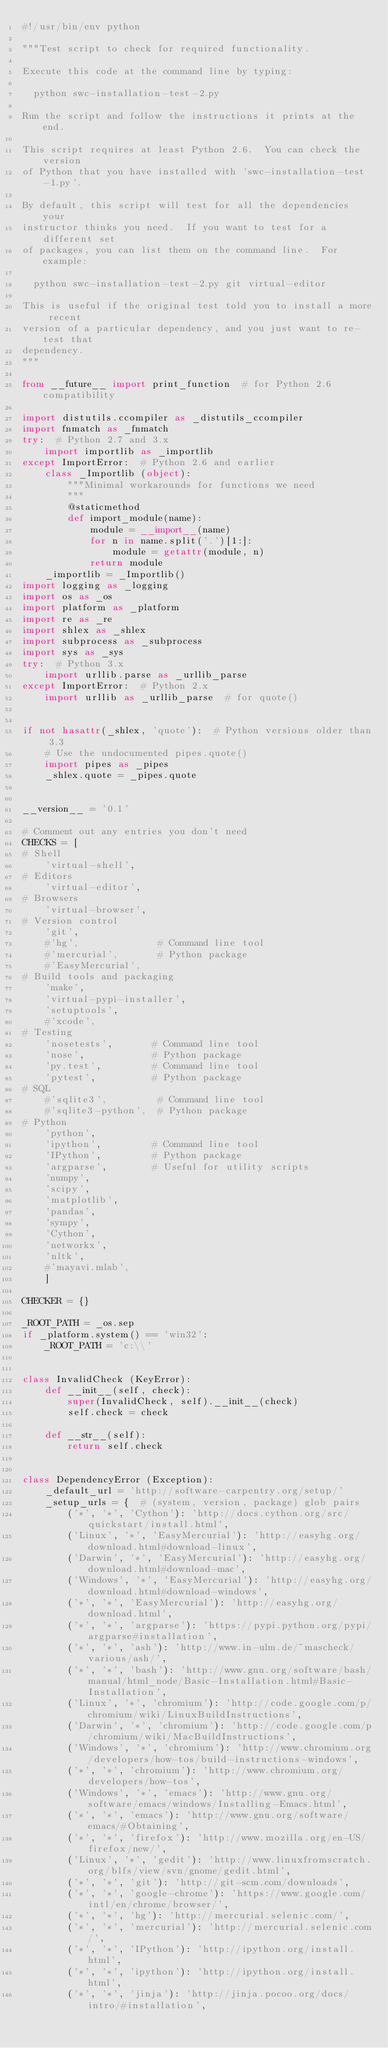Convert code to text. <code><loc_0><loc_0><loc_500><loc_500><_Python_>#!/usr/bin/env python

"""Test script to check for required functionality.

Execute this code at the command line by typing:

  python swc-installation-test-2.py

Run the script and follow the instructions it prints at the end.

This script requires at least Python 2.6.  You can check the version
of Python that you have installed with 'swc-installation-test-1.py'.

By default, this script will test for all the dependencies your
instructor thinks you need.  If you want to test for a different set
of packages, you can list them on the command line.  For example:

  python swc-installation-test-2.py git virtual-editor

This is useful if the original test told you to install a more recent
version of a particular dependency, and you just want to re-test that
dependency.
"""

from __future__ import print_function  # for Python 2.6 compatibility

import distutils.ccompiler as _distutils_ccompiler
import fnmatch as _fnmatch
try:  # Python 2.7 and 3.x
    import importlib as _importlib
except ImportError:  # Python 2.6 and earlier
    class _Importlib (object):
        """Minimal workarounds for functions we need
        """
        @staticmethod
        def import_module(name):
            module = __import__(name)
            for n in name.split('.')[1:]:
                module = getattr(module, n)
            return module
    _importlib = _Importlib()
import logging as _logging
import os as _os
import platform as _platform
import re as _re
import shlex as _shlex
import subprocess as _subprocess
import sys as _sys
try:  # Python 3.x
    import urllib.parse as _urllib_parse
except ImportError:  # Python 2.x
    import urllib as _urllib_parse  # for quote()


if not hasattr(_shlex, 'quote'):  # Python versions older than 3.3
    # Use the undocumented pipes.quote()
    import pipes as _pipes
    _shlex.quote = _pipes.quote


__version__ = '0.1'

# Comment out any entries you don't need
CHECKS = [
# Shell
    'virtual-shell',
# Editors
    'virtual-editor',
# Browsers
    'virtual-browser',
# Version control
    'git',
    #'hg',              # Command line tool
    #'mercurial',       # Python package
    #'EasyMercurial',
# Build tools and packaging
    'make',
    'virtual-pypi-installer',
    'setuptools',
    #'xcode',
# Testing
    'nosetests',       # Command line tool
    'nose',            # Python package
    'py.test',         # Command line tool
    'pytest',          # Python package
# SQL
    #'sqlite3',         # Command line tool
    #'sqlite3-python',  # Python package
# Python
    'python',
    'ipython',         # Command line tool
    'IPython',         # Python package
    'argparse',        # Useful for utility scripts
    'numpy',
    'scipy',
    'matplotlib',
    'pandas',
    'sympy',
    'Cython',
    'networkx',
    'nltk',
    #'mayavi.mlab',
    ]

CHECKER = {}

_ROOT_PATH = _os.sep
if _platform.system() == 'win32':
    _ROOT_PATH = 'c:\\'


class InvalidCheck (KeyError):
    def __init__(self, check):
        super(InvalidCheck, self).__init__(check)
        self.check = check

    def __str__(self):
        return self.check


class DependencyError (Exception):
    _default_url = 'http://software-carpentry.org/setup/'
    _setup_urls = {  # (system, version, package) glob pairs
        ('*', '*', 'Cython'): 'http://docs.cython.org/src/quickstart/install.html',
        ('Linux', '*', 'EasyMercurial'): 'http://easyhg.org/download.html#download-linux',
        ('Darwin', '*', 'EasyMercurial'): 'http://easyhg.org/download.html#download-mac',
        ('Windows', '*', 'EasyMercurial'): 'http://easyhg.org/download.html#download-windows',
        ('*', '*', 'EasyMercurial'): 'http://easyhg.org/download.html',
        ('*', '*', 'argparse'): 'https://pypi.python.org/pypi/argparse#installation',
        ('*', '*', 'ash'): 'http://www.in-ulm.de/~mascheck/various/ash/',
        ('*', '*', 'bash'): 'http://www.gnu.org/software/bash/manual/html_node/Basic-Installation.html#Basic-Installation',
        ('Linux', '*', 'chromium'): 'http://code.google.com/p/chromium/wiki/LinuxBuildInstructions',
        ('Darwin', '*', 'chromium'): 'http://code.google.com/p/chromium/wiki/MacBuildInstructions',
        ('Windows', '*', 'chromium'): 'http://www.chromium.org/developers/how-tos/build-instructions-windows',
        ('*', '*', 'chromium'): 'http://www.chromium.org/developers/how-tos',
        ('Windows', '*', 'emacs'): 'http://www.gnu.org/software/emacs/windows/Installing-Emacs.html',
        ('*', '*', 'emacs'): 'http://www.gnu.org/software/emacs/#Obtaining',
        ('*', '*', 'firefox'): 'http://www.mozilla.org/en-US/firefox/new/',
        ('Linux', '*', 'gedit'): 'http://www.linuxfromscratch.org/blfs/view/svn/gnome/gedit.html',
        ('*', '*', 'git'): 'http://git-scm.com/downloads',
        ('*', '*', 'google-chrome'): 'https://www.google.com/intl/en/chrome/browser/',
        ('*', '*', 'hg'): 'http://mercurial.selenic.com/',
        ('*', '*', 'mercurial'): 'http://mercurial.selenic.com/',
        ('*', '*', 'IPython'): 'http://ipython.org/install.html',
        ('*', '*', 'ipython'): 'http://ipython.org/install.html',
        ('*', '*', 'jinja'): 'http://jinja.pocoo.org/docs/intro/#installation',</code> 